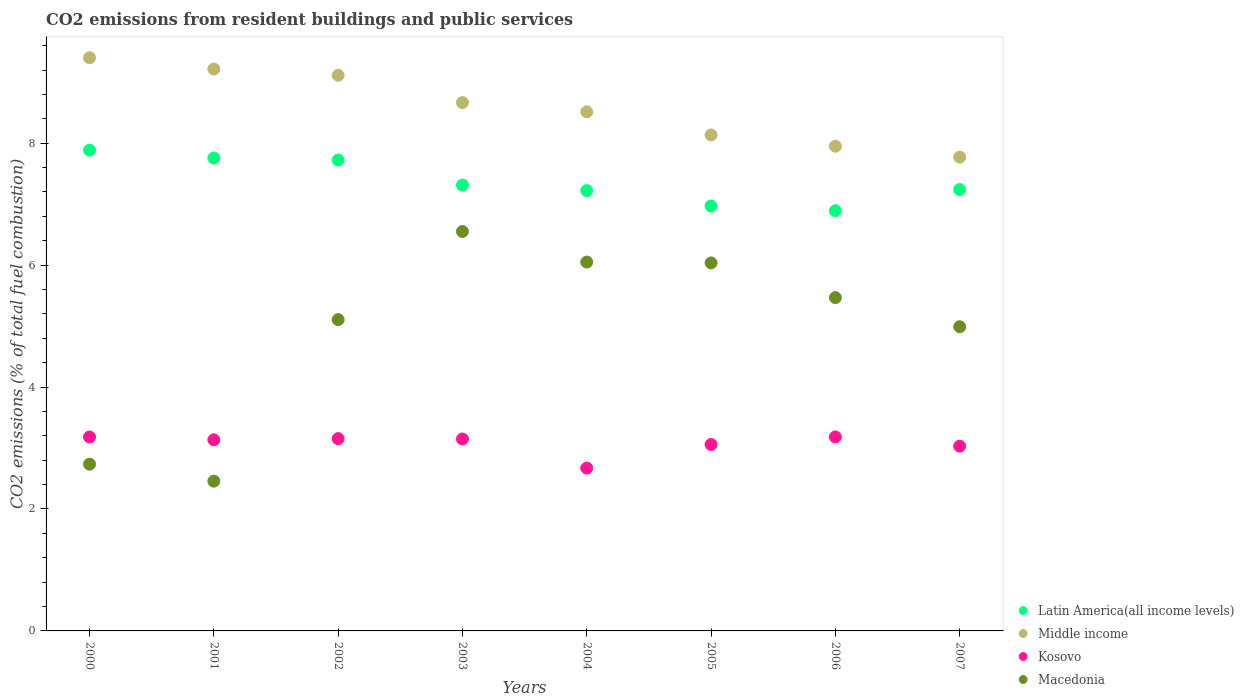What is the total CO2 emitted in Macedonia in 2002?
Give a very brief answer. 5.11. Across all years, what is the maximum total CO2 emitted in Kosovo?
Offer a very short reply. 3.18. Across all years, what is the minimum total CO2 emitted in Macedonia?
Provide a succinct answer. 2.46. In which year was the total CO2 emitted in Macedonia maximum?
Provide a short and direct response. 2003. In which year was the total CO2 emitted in Kosovo minimum?
Your answer should be compact. 2004. What is the total total CO2 emitted in Middle income in the graph?
Your response must be concise. 68.77. What is the difference between the total CO2 emitted in Middle income in 2000 and that in 2005?
Provide a short and direct response. 1.27. What is the difference between the total CO2 emitted in Middle income in 2002 and the total CO2 emitted in Latin America(all income levels) in 2003?
Provide a succinct answer. 1.8. What is the average total CO2 emitted in Kosovo per year?
Provide a short and direct response. 3.07. In the year 2003, what is the difference between the total CO2 emitted in Macedonia and total CO2 emitted in Latin America(all income levels)?
Offer a very short reply. -0.76. In how many years, is the total CO2 emitted in Middle income greater than 4.8?
Make the answer very short. 8. What is the ratio of the total CO2 emitted in Macedonia in 2001 to that in 2005?
Make the answer very short. 0.41. Is the total CO2 emitted in Latin America(all income levels) in 2002 less than that in 2004?
Your answer should be very brief. No. Is the difference between the total CO2 emitted in Macedonia in 2000 and 2005 greater than the difference between the total CO2 emitted in Latin America(all income levels) in 2000 and 2005?
Give a very brief answer. No. What is the difference between the highest and the second highest total CO2 emitted in Latin America(all income levels)?
Offer a very short reply. 0.13. What is the difference between the highest and the lowest total CO2 emitted in Middle income?
Keep it short and to the point. 1.63. Is the sum of the total CO2 emitted in Macedonia in 2002 and 2006 greater than the maximum total CO2 emitted in Kosovo across all years?
Give a very brief answer. Yes. Is it the case that in every year, the sum of the total CO2 emitted in Kosovo and total CO2 emitted in Middle income  is greater than the sum of total CO2 emitted in Macedonia and total CO2 emitted in Latin America(all income levels)?
Keep it short and to the point. No. Is the total CO2 emitted in Middle income strictly less than the total CO2 emitted in Latin America(all income levels) over the years?
Ensure brevity in your answer.  No. How many dotlines are there?
Keep it short and to the point. 4. How many years are there in the graph?
Ensure brevity in your answer.  8. Does the graph contain grids?
Offer a very short reply. No. How are the legend labels stacked?
Provide a short and direct response. Vertical. What is the title of the graph?
Your response must be concise. CO2 emissions from resident buildings and public services. What is the label or title of the Y-axis?
Keep it short and to the point. CO2 emissions (% of total fuel combustion). What is the CO2 emissions (% of total fuel combustion) in Latin America(all income levels) in 2000?
Your answer should be very brief. 7.89. What is the CO2 emissions (% of total fuel combustion) of Middle income in 2000?
Keep it short and to the point. 9.4. What is the CO2 emissions (% of total fuel combustion) of Kosovo in 2000?
Keep it short and to the point. 3.18. What is the CO2 emissions (% of total fuel combustion) in Macedonia in 2000?
Your response must be concise. 2.73. What is the CO2 emissions (% of total fuel combustion) in Latin America(all income levels) in 2001?
Your answer should be very brief. 7.76. What is the CO2 emissions (% of total fuel combustion) of Middle income in 2001?
Your response must be concise. 9.22. What is the CO2 emissions (% of total fuel combustion) in Kosovo in 2001?
Make the answer very short. 3.13. What is the CO2 emissions (% of total fuel combustion) in Macedonia in 2001?
Your answer should be very brief. 2.46. What is the CO2 emissions (% of total fuel combustion) of Latin America(all income levels) in 2002?
Make the answer very short. 7.72. What is the CO2 emissions (% of total fuel combustion) of Middle income in 2002?
Your answer should be compact. 9.11. What is the CO2 emissions (% of total fuel combustion) in Kosovo in 2002?
Offer a very short reply. 3.15. What is the CO2 emissions (% of total fuel combustion) of Macedonia in 2002?
Provide a succinct answer. 5.11. What is the CO2 emissions (% of total fuel combustion) in Latin America(all income levels) in 2003?
Provide a succinct answer. 7.31. What is the CO2 emissions (% of total fuel combustion) in Middle income in 2003?
Ensure brevity in your answer.  8.67. What is the CO2 emissions (% of total fuel combustion) in Kosovo in 2003?
Provide a short and direct response. 3.15. What is the CO2 emissions (% of total fuel combustion) of Macedonia in 2003?
Offer a terse response. 6.55. What is the CO2 emissions (% of total fuel combustion) of Latin America(all income levels) in 2004?
Your response must be concise. 7.22. What is the CO2 emissions (% of total fuel combustion) in Middle income in 2004?
Provide a short and direct response. 8.51. What is the CO2 emissions (% of total fuel combustion) of Kosovo in 2004?
Your answer should be very brief. 2.67. What is the CO2 emissions (% of total fuel combustion) of Macedonia in 2004?
Keep it short and to the point. 6.05. What is the CO2 emissions (% of total fuel combustion) of Latin America(all income levels) in 2005?
Keep it short and to the point. 6.97. What is the CO2 emissions (% of total fuel combustion) in Middle income in 2005?
Your answer should be very brief. 8.13. What is the CO2 emissions (% of total fuel combustion) in Kosovo in 2005?
Make the answer very short. 3.06. What is the CO2 emissions (% of total fuel combustion) of Macedonia in 2005?
Offer a very short reply. 6.04. What is the CO2 emissions (% of total fuel combustion) of Latin America(all income levels) in 2006?
Your answer should be very brief. 6.89. What is the CO2 emissions (% of total fuel combustion) in Middle income in 2006?
Give a very brief answer. 7.95. What is the CO2 emissions (% of total fuel combustion) of Kosovo in 2006?
Provide a succinct answer. 3.18. What is the CO2 emissions (% of total fuel combustion) of Macedonia in 2006?
Make the answer very short. 5.47. What is the CO2 emissions (% of total fuel combustion) of Latin America(all income levels) in 2007?
Ensure brevity in your answer.  7.24. What is the CO2 emissions (% of total fuel combustion) of Middle income in 2007?
Offer a terse response. 7.77. What is the CO2 emissions (% of total fuel combustion) in Kosovo in 2007?
Your response must be concise. 3.03. What is the CO2 emissions (% of total fuel combustion) in Macedonia in 2007?
Make the answer very short. 4.99. Across all years, what is the maximum CO2 emissions (% of total fuel combustion) in Latin America(all income levels)?
Your answer should be compact. 7.89. Across all years, what is the maximum CO2 emissions (% of total fuel combustion) in Middle income?
Your answer should be very brief. 9.4. Across all years, what is the maximum CO2 emissions (% of total fuel combustion) of Kosovo?
Make the answer very short. 3.18. Across all years, what is the maximum CO2 emissions (% of total fuel combustion) in Macedonia?
Give a very brief answer. 6.55. Across all years, what is the minimum CO2 emissions (% of total fuel combustion) in Latin America(all income levels)?
Keep it short and to the point. 6.89. Across all years, what is the minimum CO2 emissions (% of total fuel combustion) of Middle income?
Your answer should be very brief. 7.77. Across all years, what is the minimum CO2 emissions (% of total fuel combustion) in Kosovo?
Keep it short and to the point. 2.67. Across all years, what is the minimum CO2 emissions (% of total fuel combustion) in Macedonia?
Your response must be concise. 2.46. What is the total CO2 emissions (% of total fuel combustion) of Latin America(all income levels) in the graph?
Provide a short and direct response. 59.01. What is the total CO2 emissions (% of total fuel combustion) of Middle income in the graph?
Give a very brief answer. 68.77. What is the total CO2 emissions (% of total fuel combustion) in Kosovo in the graph?
Your answer should be compact. 24.56. What is the total CO2 emissions (% of total fuel combustion) in Macedonia in the graph?
Make the answer very short. 39.39. What is the difference between the CO2 emissions (% of total fuel combustion) of Latin America(all income levels) in 2000 and that in 2001?
Ensure brevity in your answer.  0.13. What is the difference between the CO2 emissions (% of total fuel combustion) of Middle income in 2000 and that in 2001?
Your response must be concise. 0.18. What is the difference between the CO2 emissions (% of total fuel combustion) of Kosovo in 2000 and that in 2001?
Offer a very short reply. 0.05. What is the difference between the CO2 emissions (% of total fuel combustion) of Macedonia in 2000 and that in 2001?
Make the answer very short. 0.28. What is the difference between the CO2 emissions (% of total fuel combustion) in Latin America(all income levels) in 2000 and that in 2002?
Your answer should be very brief. 0.16. What is the difference between the CO2 emissions (% of total fuel combustion) of Middle income in 2000 and that in 2002?
Ensure brevity in your answer.  0.29. What is the difference between the CO2 emissions (% of total fuel combustion) in Kosovo in 2000 and that in 2002?
Keep it short and to the point. 0.03. What is the difference between the CO2 emissions (% of total fuel combustion) in Macedonia in 2000 and that in 2002?
Your response must be concise. -2.37. What is the difference between the CO2 emissions (% of total fuel combustion) in Latin America(all income levels) in 2000 and that in 2003?
Your response must be concise. 0.57. What is the difference between the CO2 emissions (% of total fuel combustion) in Middle income in 2000 and that in 2003?
Make the answer very short. 0.74. What is the difference between the CO2 emissions (% of total fuel combustion) in Kosovo in 2000 and that in 2003?
Offer a terse response. 0.03. What is the difference between the CO2 emissions (% of total fuel combustion) in Macedonia in 2000 and that in 2003?
Provide a short and direct response. -3.82. What is the difference between the CO2 emissions (% of total fuel combustion) in Latin America(all income levels) in 2000 and that in 2004?
Provide a succinct answer. 0.66. What is the difference between the CO2 emissions (% of total fuel combustion) in Middle income in 2000 and that in 2004?
Offer a terse response. 0.89. What is the difference between the CO2 emissions (% of total fuel combustion) of Kosovo in 2000 and that in 2004?
Your answer should be compact. 0.51. What is the difference between the CO2 emissions (% of total fuel combustion) in Macedonia in 2000 and that in 2004?
Your response must be concise. -3.31. What is the difference between the CO2 emissions (% of total fuel combustion) in Latin America(all income levels) in 2000 and that in 2005?
Your response must be concise. 0.92. What is the difference between the CO2 emissions (% of total fuel combustion) in Middle income in 2000 and that in 2005?
Provide a succinct answer. 1.27. What is the difference between the CO2 emissions (% of total fuel combustion) in Kosovo in 2000 and that in 2005?
Provide a short and direct response. 0.12. What is the difference between the CO2 emissions (% of total fuel combustion) of Macedonia in 2000 and that in 2005?
Your answer should be very brief. -3.3. What is the difference between the CO2 emissions (% of total fuel combustion) of Latin America(all income levels) in 2000 and that in 2006?
Offer a terse response. 0.99. What is the difference between the CO2 emissions (% of total fuel combustion) of Middle income in 2000 and that in 2006?
Provide a short and direct response. 1.45. What is the difference between the CO2 emissions (% of total fuel combustion) of Kosovo in 2000 and that in 2006?
Offer a very short reply. -0. What is the difference between the CO2 emissions (% of total fuel combustion) in Macedonia in 2000 and that in 2006?
Keep it short and to the point. -2.73. What is the difference between the CO2 emissions (% of total fuel combustion) in Latin America(all income levels) in 2000 and that in 2007?
Offer a very short reply. 0.65. What is the difference between the CO2 emissions (% of total fuel combustion) of Middle income in 2000 and that in 2007?
Provide a short and direct response. 1.63. What is the difference between the CO2 emissions (% of total fuel combustion) in Kosovo in 2000 and that in 2007?
Make the answer very short. 0.15. What is the difference between the CO2 emissions (% of total fuel combustion) of Macedonia in 2000 and that in 2007?
Keep it short and to the point. -2.25. What is the difference between the CO2 emissions (% of total fuel combustion) in Latin America(all income levels) in 2001 and that in 2002?
Your answer should be compact. 0.03. What is the difference between the CO2 emissions (% of total fuel combustion) in Middle income in 2001 and that in 2002?
Provide a short and direct response. 0.1. What is the difference between the CO2 emissions (% of total fuel combustion) in Kosovo in 2001 and that in 2002?
Ensure brevity in your answer.  -0.02. What is the difference between the CO2 emissions (% of total fuel combustion) of Macedonia in 2001 and that in 2002?
Your answer should be very brief. -2.65. What is the difference between the CO2 emissions (% of total fuel combustion) of Latin America(all income levels) in 2001 and that in 2003?
Ensure brevity in your answer.  0.44. What is the difference between the CO2 emissions (% of total fuel combustion) in Middle income in 2001 and that in 2003?
Offer a terse response. 0.55. What is the difference between the CO2 emissions (% of total fuel combustion) in Kosovo in 2001 and that in 2003?
Your answer should be very brief. -0.01. What is the difference between the CO2 emissions (% of total fuel combustion) in Macedonia in 2001 and that in 2003?
Ensure brevity in your answer.  -4.1. What is the difference between the CO2 emissions (% of total fuel combustion) in Latin America(all income levels) in 2001 and that in 2004?
Keep it short and to the point. 0.53. What is the difference between the CO2 emissions (% of total fuel combustion) in Middle income in 2001 and that in 2004?
Offer a very short reply. 0.7. What is the difference between the CO2 emissions (% of total fuel combustion) in Kosovo in 2001 and that in 2004?
Offer a very short reply. 0.46. What is the difference between the CO2 emissions (% of total fuel combustion) of Macedonia in 2001 and that in 2004?
Your answer should be compact. -3.59. What is the difference between the CO2 emissions (% of total fuel combustion) in Latin America(all income levels) in 2001 and that in 2005?
Ensure brevity in your answer.  0.79. What is the difference between the CO2 emissions (% of total fuel combustion) of Middle income in 2001 and that in 2005?
Keep it short and to the point. 1.08. What is the difference between the CO2 emissions (% of total fuel combustion) of Kosovo in 2001 and that in 2005?
Your answer should be compact. 0.08. What is the difference between the CO2 emissions (% of total fuel combustion) in Macedonia in 2001 and that in 2005?
Your answer should be very brief. -3.58. What is the difference between the CO2 emissions (% of total fuel combustion) of Latin America(all income levels) in 2001 and that in 2006?
Give a very brief answer. 0.86. What is the difference between the CO2 emissions (% of total fuel combustion) in Middle income in 2001 and that in 2006?
Keep it short and to the point. 1.27. What is the difference between the CO2 emissions (% of total fuel combustion) of Kosovo in 2001 and that in 2006?
Provide a short and direct response. -0.05. What is the difference between the CO2 emissions (% of total fuel combustion) in Macedonia in 2001 and that in 2006?
Keep it short and to the point. -3.01. What is the difference between the CO2 emissions (% of total fuel combustion) in Latin America(all income levels) in 2001 and that in 2007?
Your answer should be very brief. 0.52. What is the difference between the CO2 emissions (% of total fuel combustion) of Middle income in 2001 and that in 2007?
Keep it short and to the point. 1.45. What is the difference between the CO2 emissions (% of total fuel combustion) of Kosovo in 2001 and that in 2007?
Offer a very short reply. 0.1. What is the difference between the CO2 emissions (% of total fuel combustion) of Macedonia in 2001 and that in 2007?
Give a very brief answer. -2.53. What is the difference between the CO2 emissions (% of total fuel combustion) in Latin America(all income levels) in 2002 and that in 2003?
Offer a very short reply. 0.41. What is the difference between the CO2 emissions (% of total fuel combustion) in Middle income in 2002 and that in 2003?
Give a very brief answer. 0.45. What is the difference between the CO2 emissions (% of total fuel combustion) of Kosovo in 2002 and that in 2003?
Give a very brief answer. 0.01. What is the difference between the CO2 emissions (% of total fuel combustion) in Macedonia in 2002 and that in 2003?
Your answer should be very brief. -1.45. What is the difference between the CO2 emissions (% of total fuel combustion) of Latin America(all income levels) in 2002 and that in 2004?
Offer a very short reply. 0.5. What is the difference between the CO2 emissions (% of total fuel combustion) of Middle income in 2002 and that in 2004?
Your response must be concise. 0.6. What is the difference between the CO2 emissions (% of total fuel combustion) in Kosovo in 2002 and that in 2004?
Keep it short and to the point. 0.48. What is the difference between the CO2 emissions (% of total fuel combustion) in Macedonia in 2002 and that in 2004?
Your response must be concise. -0.94. What is the difference between the CO2 emissions (% of total fuel combustion) in Latin America(all income levels) in 2002 and that in 2005?
Offer a terse response. 0.76. What is the difference between the CO2 emissions (% of total fuel combustion) in Middle income in 2002 and that in 2005?
Keep it short and to the point. 0.98. What is the difference between the CO2 emissions (% of total fuel combustion) in Kosovo in 2002 and that in 2005?
Your answer should be compact. 0.1. What is the difference between the CO2 emissions (% of total fuel combustion) of Macedonia in 2002 and that in 2005?
Ensure brevity in your answer.  -0.93. What is the difference between the CO2 emissions (% of total fuel combustion) in Latin America(all income levels) in 2002 and that in 2006?
Offer a very short reply. 0.83. What is the difference between the CO2 emissions (% of total fuel combustion) in Middle income in 2002 and that in 2006?
Provide a succinct answer. 1.16. What is the difference between the CO2 emissions (% of total fuel combustion) in Kosovo in 2002 and that in 2006?
Ensure brevity in your answer.  -0.03. What is the difference between the CO2 emissions (% of total fuel combustion) in Macedonia in 2002 and that in 2006?
Your response must be concise. -0.36. What is the difference between the CO2 emissions (% of total fuel combustion) of Latin America(all income levels) in 2002 and that in 2007?
Keep it short and to the point. 0.48. What is the difference between the CO2 emissions (% of total fuel combustion) in Middle income in 2002 and that in 2007?
Your answer should be very brief. 1.34. What is the difference between the CO2 emissions (% of total fuel combustion) of Kosovo in 2002 and that in 2007?
Your answer should be compact. 0.12. What is the difference between the CO2 emissions (% of total fuel combustion) in Macedonia in 2002 and that in 2007?
Offer a terse response. 0.12. What is the difference between the CO2 emissions (% of total fuel combustion) in Latin America(all income levels) in 2003 and that in 2004?
Make the answer very short. 0.09. What is the difference between the CO2 emissions (% of total fuel combustion) in Middle income in 2003 and that in 2004?
Your answer should be very brief. 0.15. What is the difference between the CO2 emissions (% of total fuel combustion) in Kosovo in 2003 and that in 2004?
Your answer should be compact. 0.48. What is the difference between the CO2 emissions (% of total fuel combustion) in Macedonia in 2003 and that in 2004?
Provide a short and direct response. 0.5. What is the difference between the CO2 emissions (% of total fuel combustion) in Latin America(all income levels) in 2003 and that in 2005?
Ensure brevity in your answer.  0.34. What is the difference between the CO2 emissions (% of total fuel combustion) of Middle income in 2003 and that in 2005?
Keep it short and to the point. 0.53. What is the difference between the CO2 emissions (% of total fuel combustion) in Kosovo in 2003 and that in 2005?
Offer a terse response. 0.09. What is the difference between the CO2 emissions (% of total fuel combustion) of Macedonia in 2003 and that in 2005?
Offer a terse response. 0.52. What is the difference between the CO2 emissions (% of total fuel combustion) in Latin America(all income levels) in 2003 and that in 2006?
Your answer should be compact. 0.42. What is the difference between the CO2 emissions (% of total fuel combustion) in Middle income in 2003 and that in 2006?
Ensure brevity in your answer.  0.72. What is the difference between the CO2 emissions (% of total fuel combustion) in Kosovo in 2003 and that in 2006?
Keep it short and to the point. -0.03. What is the difference between the CO2 emissions (% of total fuel combustion) of Macedonia in 2003 and that in 2006?
Your answer should be very brief. 1.08. What is the difference between the CO2 emissions (% of total fuel combustion) in Latin America(all income levels) in 2003 and that in 2007?
Your answer should be very brief. 0.07. What is the difference between the CO2 emissions (% of total fuel combustion) of Middle income in 2003 and that in 2007?
Offer a very short reply. 0.89. What is the difference between the CO2 emissions (% of total fuel combustion) of Kosovo in 2003 and that in 2007?
Your answer should be compact. 0.12. What is the difference between the CO2 emissions (% of total fuel combustion) of Macedonia in 2003 and that in 2007?
Your answer should be compact. 1.56. What is the difference between the CO2 emissions (% of total fuel combustion) in Latin America(all income levels) in 2004 and that in 2005?
Your answer should be very brief. 0.25. What is the difference between the CO2 emissions (% of total fuel combustion) in Middle income in 2004 and that in 2005?
Your response must be concise. 0.38. What is the difference between the CO2 emissions (% of total fuel combustion) of Kosovo in 2004 and that in 2005?
Your answer should be compact. -0.39. What is the difference between the CO2 emissions (% of total fuel combustion) of Macedonia in 2004 and that in 2005?
Keep it short and to the point. 0.01. What is the difference between the CO2 emissions (% of total fuel combustion) in Latin America(all income levels) in 2004 and that in 2006?
Your response must be concise. 0.33. What is the difference between the CO2 emissions (% of total fuel combustion) of Middle income in 2004 and that in 2006?
Give a very brief answer. 0.56. What is the difference between the CO2 emissions (% of total fuel combustion) of Kosovo in 2004 and that in 2006?
Offer a very short reply. -0.51. What is the difference between the CO2 emissions (% of total fuel combustion) of Macedonia in 2004 and that in 2006?
Provide a short and direct response. 0.58. What is the difference between the CO2 emissions (% of total fuel combustion) in Latin America(all income levels) in 2004 and that in 2007?
Your answer should be very brief. -0.02. What is the difference between the CO2 emissions (% of total fuel combustion) of Middle income in 2004 and that in 2007?
Provide a succinct answer. 0.74. What is the difference between the CO2 emissions (% of total fuel combustion) of Kosovo in 2004 and that in 2007?
Offer a terse response. -0.36. What is the difference between the CO2 emissions (% of total fuel combustion) in Macedonia in 2004 and that in 2007?
Make the answer very short. 1.06. What is the difference between the CO2 emissions (% of total fuel combustion) of Latin America(all income levels) in 2005 and that in 2006?
Provide a short and direct response. 0.08. What is the difference between the CO2 emissions (% of total fuel combustion) of Middle income in 2005 and that in 2006?
Your answer should be compact. 0.18. What is the difference between the CO2 emissions (% of total fuel combustion) in Kosovo in 2005 and that in 2006?
Your response must be concise. -0.12. What is the difference between the CO2 emissions (% of total fuel combustion) in Macedonia in 2005 and that in 2006?
Offer a terse response. 0.57. What is the difference between the CO2 emissions (% of total fuel combustion) in Latin America(all income levels) in 2005 and that in 2007?
Provide a succinct answer. -0.27. What is the difference between the CO2 emissions (% of total fuel combustion) in Middle income in 2005 and that in 2007?
Your answer should be very brief. 0.36. What is the difference between the CO2 emissions (% of total fuel combustion) in Kosovo in 2005 and that in 2007?
Your answer should be compact. 0.03. What is the difference between the CO2 emissions (% of total fuel combustion) in Macedonia in 2005 and that in 2007?
Ensure brevity in your answer.  1.05. What is the difference between the CO2 emissions (% of total fuel combustion) in Latin America(all income levels) in 2006 and that in 2007?
Your answer should be compact. -0.35. What is the difference between the CO2 emissions (% of total fuel combustion) in Middle income in 2006 and that in 2007?
Keep it short and to the point. 0.18. What is the difference between the CO2 emissions (% of total fuel combustion) in Kosovo in 2006 and that in 2007?
Offer a very short reply. 0.15. What is the difference between the CO2 emissions (% of total fuel combustion) of Macedonia in 2006 and that in 2007?
Make the answer very short. 0.48. What is the difference between the CO2 emissions (% of total fuel combustion) of Latin America(all income levels) in 2000 and the CO2 emissions (% of total fuel combustion) of Middle income in 2001?
Keep it short and to the point. -1.33. What is the difference between the CO2 emissions (% of total fuel combustion) of Latin America(all income levels) in 2000 and the CO2 emissions (% of total fuel combustion) of Kosovo in 2001?
Give a very brief answer. 4.75. What is the difference between the CO2 emissions (% of total fuel combustion) of Latin America(all income levels) in 2000 and the CO2 emissions (% of total fuel combustion) of Macedonia in 2001?
Give a very brief answer. 5.43. What is the difference between the CO2 emissions (% of total fuel combustion) of Middle income in 2000 and the CO2 emissions (% of total fuel combustion) of Kosovo in 2001?
Provide a succinct answer. 6.27. What is the difference between the CO2 emissions (% of total fuel combustion) in Middle income in 2000 and the CO2 emissions (% of total fuel combustion) in Macedonia in 2001?
Your answer should be very brief. 6.95. What is the difference between the CO2 emissions (% of total fuel combustion) of Kosovo in 2000 and the CO2 emissions (% of total fuel combustion) of Macedonia in 2001?
Your answer should be compact. 0.72. What is the difference between the CO2 emissions (% of total fuel combustion) in Latin America(all income levels) in 2000 and the CO2 emissions (% of total fuel combustion) in Middle income in 2002?
Your answer should be very brief. -1.23. What is the difference between the CO2 emissions (% of total fuel combustion) of Latin America(all income levels) in 2000 and the CO2 emissions (% of total fuel combustion) of Kosovo in 2002?
Make the answer very short. 4.73. What is the difference between the CO2 emissions (% of total fuel combustion) in Latin America(all income levels) in 2000 and the CO2 emissions (% of total fuel combustion) in Macedonia in 2002?
Offer a terse response. 2.78. What is the difference between the CO2 emissions (% of total fuel combustion) in Middle income in 2000 and the CO2 emissions (% of total fuel combustion) in Kosovo in 2002?
Your answer should be very brief. 6.25. What is the difference between the CO2 emissions (% of total fuel combustion) of Middle income in 2000 and the CO2 emissions (% of total fuel combustion) of Macedonia in 2002?
Offer a very short reply. 4.3. What is the difference between the CO2 emissions (% of total fuel combustion) of Kosovo in 2000 and the CO2 emissions (% of total fuel combustion) of Macedonia in 2002?
Your response must be concise. -1.92. What is the difference between the CO2 emissions (% of total fuel combustion) in Latin America(all income levels) in 2000 and the CO2 emissions (% of total fuel combustion) in Middle income in 2003?
Offer a terse response. -0.78. What is the difference between the CO2 emissions (% of total fuel combustion) of Latin America(all income levels) in 2000 and the CO2 emissions (% of total fuel combustion) of Kosovo in 2003?
Offer a very short reply. 4.74. What is the difference between the CO2 emissions (% of total fuel combustion) in Latin America(all income levels) in 2000 and the CO2 emissions (% of total fuel combustion) in Macedonia in 2003?
Provide a short and direct response. 1.33. What is the difference between the CO2 emissions (% of total fuel combustion) of Middle income in 2000 and the CO2 emissions (% of total fuel combustion) of Kosovo in 2003?
Provide a succinct answer. 6.25. What is the difference between the CO2 emissions (% of total fuel combustion) of Middle income in 2000 and the CO2 emissions (% of total fuel combustion) of Macedonia in 2003?
Offer a terse response. 2.85. What is the difference between the CO2 emissions (% of total fuel combustion) of Kosovo in 2000 and the CO2 emissions (% of total fuel combustion) of Macedonia in 2003?
Ensure brevity in your answer.  -3.37. What is the difference between the CO2 emissions (% of total fuel combustion) in Latin America(all income levels) in 2000 and the CO2 emissions (% of total fuel combustion) in Middle income in 2004?
Your answer should be compact. -0.63. What is the difference between the CO2 emissions (% of total fuel combustion) of Latin America(all income levels) in 2000 and the CO2 emissions (% of total fuel combustion) of Kosovo in 2004?
Your response must be concise. 5.21. What is the difference between the CO2 emissions (% of total fuel combustion) of Latin America(all income levels) in 2000 and the CO2 emissions (% of total fuel combustion) of Macedonia in 2004?
Offer a terse response. 1.84. What is the difference between the CO2 emissions (% of total fuel combustion) in Middle income in 2000 and the CO2 emissions (% of total fuel combustion) in Kosovo in 2004?
Your answer should be very brief. 6.73. What is the difference between the CO2 emissions (% of total fuel combustion) in Middle income in 2000 and the CO2 emissions (% of total fuel combustion) in Macedonia in 2004?
Your answer should be compact. 3.35. What is the difference between the CO2 emissions (% of total fuel combustion) of Kosovo in 2000 and the CO2 emissions (% of total fuel combustion) of Macedonia in 2004?
Make the answer very short. -2.87. What is the difference between the CO2 emissions (% of total fuel combustion) in Latin America(all income levels) in 2000 and the CO2 emissions (% of total fuel combustion) in Middle income in 2005?
Ensure brevity in your answer.  -0.25. What is the difference between the CO2 emissions (% of total fuel combustion) of Latin America(all income levels) in 2000 and the CO2 emissions (% of total fuel combustion) of Kosovo in 2005?
Give a very brief answer. 4.83. What is the difference between the CO2 emissions (% of total fuel combustion) in Latin America(all income levels) in 2000 and the CO2 emissions (% of total fuel combustion) in Macedonia in 2005?
Give a very brief answer. 1.85. What is the difference between the CO2 emissions (% of total fuel combustion) in Middle income in 2000 and the CO2 emissions (% of total fuel combustion) in Kosovo in 2005?
Your answer should be compact. 6.34. What is the difference between the CO2 emissions (% of total fuel combustion) of Middle income in 2000 and the CO2 emissions (% of total fuel combustion) of Macedonia in 2005?
Give a very brief answer. 3.37. What is the difference between the CO2 emissions (% of total fuel combustion) of Kosovo in 2000 and the CO2 emissions (% of total fuel combustion) of Macedonia in 2005?
Your answer should be compact. -2.86. What is the difference between the CO2 emissions (% of total fuel combustion) of Latin America(all income levels) in 2000 and the CO2 emissions (% of total fuel combustion) of Middle income in 2006?
Make the answer very short. -0.07. What is the difference between the CO2 emissions (% of total fuel combustion) of Latin America(all income levels) in 2000 and the CO2 emissions (% of total fuel combustion) of Kosovo in 2006?
Ensure brevity in your answer.  4.7. What is the difference between the CO2 emissions (% of total fuel combustion) of Latin America(all income levels) in 2000 and the CO2 emissions (% of total fuel combustion) of Macedonia in 2006?
Make the answer very short. 2.42. What is the difference between the CO2 emissions (% of total fuel combustion) of Middle income in 2000 and the CO2 emissions (% of total fuel combustion) of Kosovo in 2006?
Offer a terse response. 6.22. What is the difference between the CO2 emissions (% of total fuel combustion) in Middle income in 2000 and the CO2 emissions (% of total fuel combustion) in Macedonia in 2006?
Your answer should be very brief. 3.93. What is the difference between the CO2 emissions (% of total fuel combustion) of Kosovo in 2000 and the CO2 emissions (% of total fuel combustion) of Macedonia in 2006?
Provide a succinct answer. -2.29. What is the difference between the CO2 emissions (% of total fuel combustion) of Latin America(all income levels) in 2000 and the CO2 emissions (% of total fuel combustion) of Middle income in 2007?
Provide a succinct answer. 0.11. What is the difference between the CO2 emissions (% of total fuel combustion) in Latin America(all income levels) in 2000 and the CO2 emissions (% of total fuel combustion) in Kosovo in 2007?
Ensure brevity in your answer.  4.86. What is the difference between the CO2 emissions (% of total fuel combustion) of Latin America(all income levels) in 2000 and the CO2 emissions (% of total fuel combustion) of Macedonia in 2007?
Provide a succinct answer. 2.9. What is the difference between the CO2 emissions (% of total fuel combustion) in Middle income in 2000 and the CO2 emissions (% of total fuel combustion) in Kosovo in 2007?
Your response must be concise. 6.37. What is the difference between the CO2 emissions (% of total fuel combustion) of Middle income in 2000 and the CO2 emissions (% of total fuel combustion) of Macedonia in 2007?
Your response must be concise. 4.41. What is the difference between the CO2 emissions (% of total fuel combustion) of Kosovo in 2000 and the CO2 emissions (% of total fuel combustion) of Macedonia in 2007?
Offer a very short reply. -1.81. What is the difference between the CO2 emissions (% of total fuel combustion) in Latin America(all income levels) in 2001 and the CO2 emissions (% of total fuel combustion) in Middle income in 2002?
Your response must be concise. -1.36. What is the difference between the CO2 emissions (% of total fuel combustion) of Latin America(all income levels) in 2001 and the CO2 emissions (% of total fuel combustion) of Kosovo in 2002?
Provide a succinct answer. 4.6. What is the difference between the CO2 emissions (% of total fuel combustion) of Latin America(all income levels) in 2001 and the CO2 emissions (% of total fuel combustion) of Macedonia in 2002?
Your response must be concise. 2.65. What is the difference between the CO2 emissions (% of total fuel combustion) of Middle income in 2001 and the CO2 emissions (% of total fuel combustion) of Kosovo in 2002?
Give a very brief answer. 6.06. What is the difference between the CO2 emissions (% of total fuel combustion) in Middle income in 2001 and the CO2 emissions (% of total fuel combustion) in Macedonia in 2002?
Your answer should be compact. 4.11. What is the difference between the CO2 emissions (% of total fuel combustion) of Kosovo in 2001 and the CO2 emissions (% of total fuel combustion) of Macedonia in 2002?
Your answer should be compact. -1.97. What is the difference between the CO2 emissions (% of total fuel combustion) of Latin America(all income levels) in 2001 and the CO2 emissions (% of total fuel combustion) of Middle income in 2003?
Provide a short and direct response. -0.91. What is the difference between the CO2 emissions (% of total fuel combustion) of Latin America(all income levels) in 2001 and the CO2 emissions (% of total fuel combustion) of Kosovo in 2003?
Your answer should be very brief. 4.61. What is the difference between the CO2 emissions (% of total fuel combustion) of Latin America(all income levels) in 2001 and the CO2 emissions (% of total fuel combustion) of Macedonia in 2003?
Your answer should be compact. 1.21. What is the difference between the CO2 emissions (% of total fuel combustion) of Middle income in 2001 and the CO2 emissions (% of total fuel combustion) of Kosovo in 2003?
Offer a very short reply. 6.07. What is the difference between the CO2 emissions (% of total fuel combustion) in Middle income in 2001 and the CO2 emissions (% of total fuel combustion) in Macedonia in 2003?
Keep it short and to the point. 2.66. What is the difference between the CO2 emissions (% of total fuel combustion) in Kosovo in 2001 and the CO2 emissions (% of total fuel combustion) in Macedonia in 2003?
Your response must be concise. -3.42. What is the difference between the CO2 emissions (% of total fuel combustion) in Latin America(all income levels) in 2001 and the CO2 emissions (% of total fuel combustion) in Middle income in 2004?
Your answer should be compact. -0.76. What is the difference between the CO2 emissions (% of total fuel combustion) of Latin America(all income levels) in 2001 and the CO2 emissions (% of total fuel combustion) of Kosovo in 2004?
Offer a terse response. 5.09. What is the difference between the CO2 emissions (% of total fuel combustion) in Latin America(all income levels) in 2001 and the CO2 emissions (% of total fuel combustion) in Macedonia in 2004?
Offer a very short reply. 1.71. What is the difference between the CO2 emissions (% of total fuel combustion) of Middle income in 2001 and the CO2 emissions (% of total fuel combustion) of Kosovo in 2004?
Your response must be concise. 6.55. What is the difference between the CO2 emissions (% of total fuel combustion) of Middle income in 2001 and the CO2 emissions (% of total fuel combustion) of Macedonia in 2004?
Ensure brevity in your answer.  3.17. What is the difference between the CO2 emissions (% of total fuel combustion) in Kosovo in 2001 and the CO2 emissions (% of total fuel combustion) in Macedonia in 2004?
Keep it short and to the point. -2.92. What is the difference between the CO2 emissions (% of total fuel combustion) of Latin America(all income levels) in 2001 and the CO2 emissions (% of total fuel combustion) of Middle income in 2005?
Offer a very short reply. -0.38. What is the difference between the CO2 emissions (% of total fuel combustion) of Latin America(all income levels) in 2001 and the CO2 emissions (% of total fuel combustion) of Kosovo in 2005?
Offer a very short reply. 4.7. What is the difference between the CO2 emissions (% of total fuel combustion) of Latin America(all income levels) in 2001 and the CO2 emissions (% of total fuel combustion) of Macedonia in 2005?
Offer a very short reply. 1.72. What is the difference between the CO2 emissions (% of total fuel combustion) of Middle income in 2001 and the CO2 emissions (% of total fuel combustion) of Kosovo in 2005?
Your answer should be very brief. 6.16. What is the difference between the CO2 emissions (% of total fuel combustion) of Middle income in 2001 and the CO2 emissions (% of total fuel combustion) of Macedonia in 2005?
Ensure brevity in your answer.  3.18. What is the difference between the CO2 emissions (% of total fuel combustion) of Kosovo in 2001 and the CO2 emissions (% of total fuel combustion) of Macedonia in 2005?
Ensure brevity in your answer.  -2.9. What is the difference between the CO2 emissions (% of total fuel combustion) in Latin America(all income levels) in 2001 and the CO2 emissions (% of total fuel combustion) in Middle income in 2006?
Make the answer very short. -0.19. What is the difference between the CO2 emissions (% of total fuel combustion) of Latin America(all income levels) in 2001 and the CO2 emissions (% of total fuel combustion) of Kosovo in 2006?
Your response must be concise. 4.58. What is the difference between the CO2 emissions (% of total fuel combustion) of Latin America(all income levels) in 2001 and the CO2 emissions (% of total fuel combustion) of Macedonia in 2006?
Offer a terse response. 2.29. What is the difference between the CO2 emissions (% of total fuel combustion) in Middle income in 2001 and the CO2 emissions (% of total fuel combustion) in Kosovo in 2006?
Keep it short and to the point. 6.03. What is the difference between the CO2 emissions (% of total fuel combustion) in Middle income in 2001 and the CO2 emissions (% of total fuel combustion) in Macedonia in 2006?
Provide a succinct answer. 3.75. What is the difference between the CO2 emissions (% of total fuel combustion) of Kosovo in 2001 and the CO2 emissions (% of total fuel combustion) of Macedonia in 2006?
Your answer should be very brief. -2.33. What is the difference between the CO2 emissions (% of total fuel combustion) of Latin America(all income levels) in 2001 and the CO2 emissions (% of total fuel combustion) of Middle income in 2007?
Make the answer very short. -0.01. What is the difference between the CO2 emissions (% of total fuel combustion) of Latin America(all income levels) in 2001 and the CO2 emissions (% of total fuel combustion) of Kosovo in 2007?
Provide a succinct answer. 4.73. What is the difference between the CO2 emissions (% of total fuel combustion) in Latin America(all income levels) in 2001 and the CO2 emissions (% of total fuel combustion) in Macedonia in 2007?
Provide a short and direct response. 2.77. What is the difference between the CO2 emissions (% of total fuel combustion) of Middle income in 2001 and the CO2 emissions (% of total fuel combustion) of Kosovo in 2007?
Provide a succinct answer. 6.19. What is the difference between the CO2 emissions (% of total fuel combustion) of Middle income in 2001 and the CO2 emissions (% of total fuel combustion) of Macedonia in 2007?
Offer a terse response. 4.23. What is the difference between the CO2 emissions (% of total fuel combustion) in Kosovo in 2001 and the CO2 emissions (% of total fuel combustion) in Macedonia in 2007?
Provide a succinct answer. -1.85. What is the difference between the CO2 emissions (% of total fuel combustion) of Latin America(all income levels) in 2002 and the CO2 emissions (% of total fuel combustion) of Middle income in 2003?
Offer a terse response. -0.94. What is the difference between the CO2 emissions (% of total fuel combustion) of Latin America(all income levels) in 2002 and the CO2 emissions (% of total fuel combustion) of Kosovo in 2003?
Make the answer very short. 4.58. What is the difference between the CO2 emissions (% of total fuel combustion) in Latin America(all income levels) in 2002 and the CO2 emissions (% of total fuel combustion) in Macedonia in 2003?
Keep it short and to the point. 1.17. What is the difference between the CO2 emissions (% of total fuel combustion) of Middle income in 2002 and the CO2 emissions (% of total fuel combustion) of Kosovo in 2003?
Keep it short and to the point. 5.97. What is the difference between the CO2 emissions (% of total fuel combustion) in Middle income in 2002 and the CO2 emissions (% of total fuel combustion) in Macedonia in 2003?
Give a very brief answer. 2.56. What is the difference between the CO2 emissions (% of total fuel combustion) in Kosovo in 2002 and the CO2 emissions (% of total fuel combustion) in Macedonia in 2003?
Give a very brief answer. -3.4. What is the difference between the CO2 emissions (% of total fuel combustion) of Latin America(all income levels) in 2002 and the CO2 emissions (% of total fuel combustion) of Middle income in 2004?
Provide a succinct answer. -0.79. What is the difference between the CO2 emissions (% of total fuel combustion) in Latin America(all income levels) in 2002 and the CO2 emissions (% of total fuel combustion) in Kosovo in 2004?
Your answer should be very brief. 5.05. What is the difference between the CO2 emissions (% of total fuel combustion) in Latin America(all income levels) in 2002 and the CO2 emissions (% of total fuel combustion) in Macedonia in 2004?
Make the answer very short. 1.67. What is the difference between the CO2 emissions (% of total fuel combustion) in Middle income in 2002 and the CO2 emissions (% of total fuel combustion) in Kosovo in 2004?
Keep it short and to the point. 6.44. What is the difference between the CO2 emissions (% of total fuel combustion) of Middle income in 2002 and the CO2 emissions (% of total fuel combustion) of Macedonia in 2004?
Make the answer very short. 3.06. What is the difference between the CO2 emissions (% of total fuel combustion) in Kosovo in 2002 and the CO2 emissions (% of total fuel combustion) in Macedonia in 2004?
Provide a succinct answer. -2.9. What is the difference between the CO2 emissions (% of total fuel combustion) in Latin America(all income levels) in 2002 and the CO2 emissions (% of total fuel combustion) in Middle income in 2005?
Provide a succinct answer. -0.41. What is the difference between the CO2 emissions (% of total fuel combustion) in Latin America(all income levels) in 2002 and the CO2 emissions (% of total fuel combustion) in Kosovo in 2005?
Provide a succinct answer. 4.67. What is the difference between the CO2 emissions (% of total fuel combustion) of Latin America(all income levels) in 2002 and the CO2 emissions (% of total fuel combustion) of Macedonia in 2005?
Ensure brevity in your answer.  1.69. What is the difference between the CO2 emissions (% of total fuel combustion) of Middle income in 2002 and the CO2 emissions (% of total fuel combustion) of Kosovo in 2005?
Make the answer very short. 6.06. What is the difference between the CO2 emissions (% of total fuel combustion) in Middle income in 2002 and the CO2 emissions (% of total fuel combustion) in Macedonia in 2005?
Keep it short and to the point. 3.08. What is the difference between the CO2 emissions (% of total fuel combustion) in Kosovo in 2002 and the CO2 emissions (% of total fuel combustion) in Macedonia in 2005?
Your answer should be compact. -2.88. What is the difference between the CO2 emissions (% of total fuel combustion) in Latin America(all income levels) in 2002 and the CO2 emissions (% of total fuel combustion) in Middle income in 2006?
Give a very brief answer. -0.23. What is the difference between the CO2 emissions (% of total fuel combustion) in Latin America(all income levels) in 2002 and the CO2 emissions (% of total fuel combustion) in Kosovo in 2006?
Provide a succinct answer. 4.54. What is the difference between the CO2 emissions (% of total fuel combustion) in Latin America(all income levels) in 2002 and the CO2 emissions (% of total fuel combustion) in Macedonia in 2006?
Provide a short and direct response. 2.26. What is the difference between the CO2 emissions (% of total fuel combustion) in Middle income in 2002 and the CO2 emissions (% of total fuel combustion) in Kosovo in 2006?
Your answer should be compact. 5.93. What is the difference between the CO2 emissions (% of total fuel combustion) of Middle income in 2002 and the CO2 emissions (% of total fuel combustion) of Macedonia in 2006?
Provide a short and direct response. 3.65. What is the difference between the CO2 emissions (% of total fuel combustion) of Kosovo in 2002 and the CO2 emissions (% of total fuel combustion) of Macedonia in 2006?
Make the answer very short. -2.31. What is the difference between the CO2 emissions (% of total fuel combustion) in Latin America(all income levels) in 2002 and the CO2 emissions (% of total fuel combustion) in Middle income in 2007?
Provide a succinct answer. -0.05. What is the difference between the CO2 emissions (% of total fuel combustion) in Latin America(all income levels) in 2002 and the CO2 emissions (% of total fuel combustion) in Kosovo in 2007?
Keep it short and to the point. 4.69. What is the difference between the CO2 emissions (% of total fuel combustion) of Latin America(all income levels) in 2002 and the CO2 emissions (% of total fuel combustion) of Macedonia in 2007?
Your answer should be compact. 2.74. What is the difference between the CO2 emissions (% of total fuel combustion) in Middle income in 2002 and the CO2 emissions (% of total fuel combustion) in Kosovo in 2007?
Provide a short and direct response. 6.08. What is the difference between the CO2 emissions (% of total fuel combustion) in Middle income in 2002 and the CO2 emissions (% of total fuel combustion) in Macedonia in 2007?
Give a very brief answer. 4.12. What is the difference between the CO2 emissions (% of total fuel combustion) in Kosovo in 2002 and the CO2 emissions (% of total fuel combustion) in Macedonia in 2007?
Ensure brevity in your answer.  -1.83. What is the difference between the CO2 emissions (% of total fuel combustion) of Latin America(all income levels) in 2003 and the CO2 emissions (% of total fuel combustion) of Middle income in 2004?
Keep it short and to the point. -1.2. What is the difference between the CO2 emissions (% of total fuel combustion) of Latin America(all income levels) in 2003 and the CO2 emissions (% of total fuel combustion) of Kosovo in 2004?
Provide a succinct answer. 4.64. What is the difference between the CO2 emissions (% of total fuel combustion) in Latin America(all income levels) in 2003 and the CO2 emissions (% of total fuel combustion) in Macedonia in 2004?
Provide a short and direct response. 1.26. What is the difference between the CO2 emissions (% of total fuel combustion) in Middle income in 2003 and the CO2 emissions (% of total fuel combustion) in Kosovo in 2004?
Give a very brief answer. 6. What is the difference between the CO2 emissions (% of total fuel combustion) in Middle income in 2003 and the CO2 emissions (% of total fuel combustion) in Macedonia in 2004?
Your answer should be compact. 2.62. What is the difference between the CO2 emissions (% of total fuel combustion) of Kosovo in 2003 and the CO2 emissions (% of total fuel combustion) of Macedonia in 2004?
Your response must be concise. -2.9. What is the difference between the CO2 emissions (% of total fuel combustion) of Latin America(all income levels) in 2003 and the CO2 emissions (% of total fuel combustion) of Middle income in 2005?
Your response must be concise. -0.82. What is the difference between the CO2 emissions (% of total fuel combustion) in Latin America(all income levels) in 2003 and the CO2 emissions (% of total fuel combustion) in Kosovo in 2005?
Your answer should be very brief. 4.26. What is the difference between the CO2 emissions (% of total fuel combustion) in Latin America(all income levels) in 2003 and the CO2 emissions (% of total fuel combustion) in Macedonia in 2005?
Give a very brief answer. 1.28. What is the difference between the CO2 emissions (% of total fuel combustion) in Middle income in 2003 and the CO2 emissions (% of total fuel combustion) in Kosovo in 2005?
Offer a very short reply. 5.61. What is the difference between the CO2 emissions (% of total fuel combustion) in Middle income in 2003 and the CO2 emissions (% of total fuel combustion) in Macedonia in 2005?
Provide a short and direct response. 2.63. What is the difference between the CO2 emissions (% of total fuel combustion) in Kosovo in 2003 and the CO2 emissions (% of total fuel combustion) in Macedonia in 2005?
Ensure brevity in your answer.  -2.89. What is the difference between the CO2 emissions (% of total fuel combustion) of Latin America(all income levels) in 2003 and the CO2 emissions (% of total fuel combustion) of Middle income in 2006?
Your response must be concise. -0.64. What is the difference between the CO2 emissions (% of total fuel combustion) of Latin America(all income levels) in 2003 and the CO2 emissions (% of total fuel combustion) of Kosovo in 2006?
Offer a very short reply. 4.13. What is the difference between the CO2 emissions (% of total fuel combustion) in Latin America(all income levels) in 2003 and the CO2 emissions (% of total fuel combustion) in Macedonia in 2006?
Your response must be concise. 1.85. What is the difference between the CO2 emissions (% of total fuel combustion) of Middle income in 2003 and the CO2 emissions (% of total fuel combustion) of Kosovo in 2006?
Make the answer very short. 5.48. What is the difference between the CO2 emissions (% of total fuel combustion) in Middle income in 2003 and the CO2 emissions (% of total fuel combustion) in Macedonia in 2006?
Your response must be concise. 3.2. What is the difference between the CO2 emissions (% of total fuel combustion) in Kosovo in 2003 and the CO2 emissions (% of total fuel combustion) in Macedonia in 2006?
Your answer should be compact. -2.32. What is the difference between the CO2 emissions (% of total fuel combustion) in Latin America(all income levels) in 2003 and the CO2 emissions (% of total fuel combustion) in Middle income in 2007?
Provide a succinct answer. -0.46. What is the difference between the CO2 emissions (% of total fuel combustion) in Latin America(all income levels) in 2003 and the CO2 emissions (% of total fuel combustion) in Kosovo in 2007?
Give a very brief answer. 4.28. What is the difference between the CO2 emissions (% of total fuel combustion) of Latin America(all income levels) in 2003 and the CO2 emissions (% of total fuel combustion) of Macedonia in 2007?
Offer a terse response. 2.32. What is the difference between the CO2 emissions (% of total fuel combustion) in Middle income in 2003 and the CO2 emissions (% of total fuel combustion) in Kosovo in 2007?
Ensure brevity in your answer.  5.64. What is the difference between the CO2 emissions (% of total fuel combustion) of Middle income in 2003 and the CO2 emissions (% of total fuel combustion) of Macedonia in 2007?
Offer a terse response. 3.68. What is the difference between the CO2 emissions (% of total fuel combustion) of Kosovo in 2003 and the CO2 emissions (% of total fuel combustion) of Macedonia in 2007?
Make the answer very short. -1.84. What is the difference between the CO2 emissions (% of total fuel combustion) of Latin America(all income levels) in 2004 and the CO2 emissions (% of total fuel combustion) of Middle income in 2005?
Ensure brevity in your answer.  -0.91. What is the difference between the CO2 emissions (% of total fuel combustion) in Latin America(all income levels) in 2004 and the CO2 emissions (% of total fuel combustion) in Kosovo in 2005?
Provide a succinct answer. 4.16. What is the difference between the CO2 emissions (% of total fuel combustion) in Latin America(all income levels) in 2004 and the CO2 emissions (% of total fuel combustion) in Macedonia in 2005?
Your answer should be very brief. 1.19. What is the difference between the CO2 emissions (% of total fuel combustion) of Middle income in 2004 and the CO2 emissions (% of total fuel combustion) of Kosovo in 2005?
Your answer should be compact. 5.46. What is the difference between the CO2 emissions (% of total fuel combustion) of Middle income in 2004 and the CO2 emissions (% of total fuel combustion) of Macedonia in 2005?
Your response must be concise. 2.48. What is the difference between the CO2 emissions (% of total fuel combustion) in Kosovo in 2004 and the CO2 emissions (% of total fuel combustion) in Macedonia in 2005?
Offer a very short reply. -3.37. What is the difference between the CO2 emissions (% of total fuel combustion) of Latin America(all income levels) in 2004 and the CO2 emissions (% of total fuel combustion) of Middle income in 2006?
Your response must be concise. -0.73. What is the difference between the CO2 emissions (% of total fuel combustion) in Latin America(all income levels) in 2004 and the CO2 emissions (% of total fuel combustion) in Kosovo in 2006?
Offer a very short reply. 4.04. What is the difference between the CO2 emissions (% of total fuel combustion) in Latin America(all income levels) in 2004 and the CO2 emissions (% of total fuel combustion) in Macedonia in 2006?
Your answer should be compact. 1.76. What is the difference between the CO2 emissions (% of total fuel combustion) in Middle income in 2004 and the CO2 emissions (% of total fuel combustion) in Kosovo in 2006?
Give a very brief answer. 5.33. What is the difference between the CO2 emissions (% of total fuel combustion) in Middle income in 2004 and the CO2 emissions (% of total fuel combustion) in Macedonia in 2006?
Your response must be concise. 3.05. What is the difference between the CO2 emissions (% of total fuel combustion) of Kosovo in 2004 and the CO2 emissions (% of total fuel combustion) of Macedonia in 2006?
Make the answer very short. -2.8. What is the difference between the CO2 emissions (% of total fuel combustion) in Latin America(all income levels) in 2004 and the CO2 emissions (% of total fuel combustion) in Middle income in 2007?
Provide a short and direct response. -0.55. What is the difference between the CO2 emissions (% of total fuel combustion) of Latin America(all income levels) in 2004 and the CO2 emissions (% of total fuel combustion) of Kosovo in 2007?
Provide a short and direct response. 4.19. What is the difference between the CO2 emissions (% of total fuel combustion) of Latin America(all income levels) in 2004 and the CO2 emissions (% of total fuel combustion) of Macedonia in 2007?
Make the answer very short. 2.23. What is the difference between the CO2 emissions (% of total fuel combustion) in Middle income in 2004 and the CO2 emissions (% of total fuel combustion) in Kosovo in 2007?
Keep it short and to the point. 5.48. What is the difference between the CO2 emissions (% of total fuel combustion) in Middle income in 2004 and the CO2 emissions (% of total fuel combustion) in Macedonia in 2007?
Offer a terse response. 3.52. What is the difference between the CO2 emissions (% of total fuel combustion) of Kosovo in 2004 and the CO2 emissions (% of total fuel combustion) of Macedonia in 2007?
Your answer should be compact. -2.32. What is the difference between the CO2 emissions (% of total fuel combustion) in Latin America(all income levels) in 2005 and the CO2 emissions (% of total fuel combustion) in Middle income in 2006?
Provide a short and direct response. -0.98. What is the difference between the CO2 emissions (% of total fuel combustion) in Latin America(all income levels) in 2005 and the CO2 emissions (% of total fuel combustion) in Kosovo in 2006?
Keep it short and to the point. 3.79. What is the difference between the CO2 emissions (% of total fuel combustion) in Latin America(all income levels) in 2005 and the CO2 emissions (% of total fuel combustion) in Macedonia in 2006?
Provide a short and direct response. 1.5. What is the difference between the CO2 emissions (% of total fuel combustion) of Middle income in 2005 and the CO2 emissions (% of total fuel combustion) of Kosovo in 2006?
Offer a terse response. 4.95. What is the difference between the CO2 emissions (% of total fuel combustion) in Middle income in 2005 and the CO2 emissions (% of total fuel combustion) in Macedonia in 2006?
Offer a very short reply. 2.67. What is the difference between the CO2 emissions (% of total fuel combustion) in Kosovo in 2005 and the CO2 emissions (% of total fuel combustion) in Macedonia in 2006?
Provide a short and direct response. -2.41. What is the difference between the CO2 emissions (% of total fuel combustion) in Latin America(all income levels) in 2005 and the CO2 emissions (% of total fuel combustion) in Middle income in 2007?
Give a very brief answer. -0.8. What is the difference between the CO2 emissions (% of total fuel combustion) in Latin America(all income levels) in 2005 and the CO2 emissions (% of total fuel combustion) in Kosovo in 2007?
Give a very brief answer. 3.94. What is the difference between the CO2 emissions (% of total fuel combustion) in Latin America(all income levels) in 2005 and the CO2 emissions (% of total fuel combustion) in Macedonia in 2007?
Your answer should be compact. 1.98. What is the difference between the CO2 emissions (% of total fuel combustion) in Middle income in 2005 and the CO2 emissions (% of total fuel combustion) in Kosovo in 2007?
Make the answer very short. 5.1. What is the difference between the CO2 emissions (% of total fuel combustion) of Middle income in 2005 and the CO2 emissions (% of total fuel combustion) of Macedonia in 2007?
Keep it short and to the point. 3.15. What is the difference between the CO2 emissions (% of total fuel combustion) of Kosovo in 2005 and the CO2 emissions (% of total fuel combustion) of Macedonia in 2007?
Your answer should be compact. -1.93. What is the difference between the CO2 emissions (% of total fuel combustion) of Latin America(all income levels) in 2006 and the CO2 emissions (% of total fuel combustion) of Middle income in 2007?
Keep it short and to the point. -0.88. What is the difference between the CO2 emissions (% of total fuel combustion) in Latin America(all income levels) in 2006 and the CO2 emissions (% of total fuel combustion) in Kosovo in 2007?
Provide a succinct answer. 3.86. What is the difference between the CO2 emissions (% of total fuel combustion) in Latin America(all income levels) in 2006 and the CO2 emissions (% of total fuel combustion) in Macedonia in 2007?
Your response must be concise. 1.9. What is the difference between the CO2 emissions (% of total fuel combustion) in Middle income in 2006 and the CO2 emissions (% of total fuel combustion) in Kosovo in 2007?
Offer a very short reply. 4.92. What is the difference between the CO2 emissions (% of total fuel combustion) of Middle income in 2006 and the CO2 emissions (% of total fuel combustion) of Macedonia in 2007?
Your response must be concise. 2.96. What is the difference between the CO2 emissions (% of total fuel combustion) in Kosovo in 2006 and the CO2 emissions (% of total fuel combustion) in Macedonia in 2007?
Offer a terse response. -1.81. What is the average CO2 emissions (% of total fuel combustion) of Latin America(all income levels) per year?
Provide a short and direct response. 7.38. What is the average CO2 emissions (% of total fuel combustion) in Middle income per year?
Your answer should be very brief. 8.6. What is the average CO2 emissions (% of total fuel combustion) of Kosovo per year?
Your answer should be compact. 3.07. What is the average CO2 emissions (% of total fuel combustion) of Macedonia per year?
Offer a very short reply. 4.92. In the year 2000, what is the difference between the CO2 emissions (% of total fuel combustion) of Latin America(all income levels) and CO2 emissions (% of total fuel combustion) of Middle income?
Your answer should be very brief. -1.52. In the year 2000, what is the difference between the CO2 emissions (% of total fuel combustion) of Latin America(all income levels) and CO2 emissions (% of total fuel combustion) of Kosovo?
Make the answer very short. 4.7. In the year 2000, what is the difference between the CO2 emissions (% of total fuel combustion) in Latin America(all income levels) and CO2 emissions (% of total fuel combustion) in Macedonia?
Your response must be concise. 5.15. In the year 2000, what is the difference between the CO2 emissions (% of total fuel combustion) in Middle income and CO2 emissions (% of total fuel combustion) in Kosovo?
Give a very brief answer. 6.22. In the year 2000, what is the difference between the CO2 emissions (% of total fuel combustion) of Middle income and CO2 emissions (% of total fuel combustion) of Macedonia?
Make the answer very short. 6.67. In the year 2000, what is the difference between the CO2 emissions (% of total fuel combustion) in Kosovo and CO2 emissions (% of total fuel combustion) in Macedonia?
Give a very brief answer. 0.45. In the year 2001, what is the difference between the CO2 emissions (% of total fuel combustion) in Latin America(all income levels) and CO2 emissions (% of total fuel combustion) in Middle income?
Your answer should be very brief. -1.46. In the year 2001, what is the difference between the CO2 emissions (% of total fuel combustion) in Latin America(all income levels) and CO2 emissions (% of total fuel combustion) in Kosovo?
Your answer should be very brief. 4.62. In the year 2001, what is the difference between the CO2 emissions (% of total fuel combustion) in Latin America(all income levels) and CO2 emissions (% of total fuel combustion) in Macedonia?
Provide a succinct answer. 5.3. In the year 2001, what is the difference between the CO2 emissions (% of total fuel combustion) in Middle income and CO2 emissions (% of total fuel combustion) in Kosovo?
Offer a terse response. 6.08. In the year 2001, what is the difference between the CO2 emissions (% of total fuel combustion) of Middle income and CO2 emissions (% of total fuel combustion) of Macedonia?
Keep it short and to the point. 6.76. In the year 2001, what is the difference between the CO2 emissions (% of total fuel combustion) in Kosovo and CO2 emissions (% of total fuel combustion) in Macedonia?
Your answer should be compact. 0.68. In the year 2002, what is the difference between the CO2 emissions (% of total fuel combustion) of Latin America(all income levels) and CO2 emissions (% of total fuel combustion) of Middle income?
Your answer should be very brief. -1.39. In the year 2002, what is the difference between the CO2 emissions (% of total fuel combustion) of Latin America(all income levels) and CO2 emissions (% of total fuel combustion) of Kosovo?
Keep it short and to the point. 4.57. In the year 2002, what is the difference between the CO2 emissions (% of total fuel combustion) in Latin America(all income levels) and CO2 emissions (% of total fuel combustion) in Macedonia?
Keep it short and to the point. 2.62. In the year 2002, what is the difference between the CO2 emissions (% of total fuel combustion) in Middle income and CO2 emissions (% of total fuel combustion) in Kosovo?
Keep it short and to the point. 5.96. In the year 2002, what is the difference between the CO2 emissions (% of total fuel combustion) in Middle income and CO2 emissions (% of total fuel combustion) in Macedonia?
Provide a succinct answer. 4.01. In the year 2002, what is the difference between the CO2 emissions (% of total fuel combustion) in Kosovo and CO2 emissions (% of total fuel combustion) in Macedonia?
Keep it short and to the point. -1.95. In the year 2003, what is the difference between the CO2 emissions (% of total fuel combustion) in Latin America(all income levels) and CO2 emissions (% of total fuel combustion) in Middle income?
Offer a terse response. -1.35. In the year 2003, what is the difference between the CO2 emissions (% of total fuel combustion) in Latin America(all income levels) and CO2 emissions (% of total fuel combustion) in Kosovo?
Offer a terse response. 4.16. In the year 2003, what is the difference between the CO2 emissions (% of total fuel combustion) in Latin America(all income levels) and CO2 emissions (% of total fuel combustion) in Macedonia?
Give a very brief answer. 0.76. In the year 2003, what is the difference between the CO2 emissions (% of total fuel combustion) of Middle income and CO2 emissions (% of total fuel combustion) of Kosovo?
Your response must be concise. 5.52. In the year 2003, what is the difference between the CO2 emissions (% of total fuel combustion) in Middle income and CO2 emissions (% of total fuel combustion) in Macedonia?
Make the answer very short. 2.11. In the year 2003, what is the difference between the CO2 emissions (% of total fuel combustion) of Kosovo and CO2 emissions (% of total fuel combustion) of Macedonia?
Keep it short and to the point. -3.4. In the year 2004, what is the difference between the CO2 emissions (% of total fuel combustion) in Latin America(all income levels) and CO2 emissions (% of total fuel combustion) in Middle income?
Keep it short and to the point. -1.29. In the year 2004, what is the difference between the CO2 emissions (% of total fuel combustion) in Latin America(all income levels) and CO2 emissions (% of total fuel combustion) in Kosovo?
Keep it short and to the point. 4.55. In the year 2004, what is the difference between the CO2 emissions (% of total fuel combustion) of Latin America(all income levels) and CO2 emissions (% of total fuel combustion) of Macedonia?
Make the answer very short. 1.17. In the year 2004, what is the difference between the CO2 emissions (% of total fuel combustion) of Middle income and CO2 emissions (% of total fuel combustion) of Kosovo?
Provide a succinct answer. 5.84. In the year 2004, what is the difference between the CO2 emissions (% of total fuel combustion) in Middle income and CO2 emissions (% of total fuel combustion) in Macedonia?
Provide a short and direct response. 2.46. In the year 2004, what is the difference between the CO2 emissions (% of total fuel combustion) of Kosovo and CO2 emissions (% of total fuel combustion) of Macedonia?
Provide a succinct answer. -3.38. In the year 2005, what is the difference between the CO2 emissions (% of total fuel combustion) in Latin America(all income levels) and CO2 emissions (% of total fuel combustion) in Middle income?
Provide a succinct answer. -1.17. In the year 2005, what is the difference between the CO2 emissions (% of total fuel combustion) in Latin America(all income levels) and CO2 emissions (% of total fuel combustion) in Kosovo?
Offer a very short reply. 3.91. In the year 2005, what is the difference between the CO2 emissions (% of total fuel combustion) in Latin America(all income levels) and CO2 emissions (% of total fuel combustion) in Macedonia?
Your answer should be very brief. 0.93. In the year 2005, what is the difference between the CO2 emissions (% of total fuel combustion) in Middle income and CO2 emissions (% of total fuel combustion) in Kosovo?
Offer a very short reply. 5.08. In the year 2005, what is the difference between the CO2 emissions (% of total fuel combustion) of Middle income and CO2 emissions (% of total fuel combustion) of Macedonia?
Give a very brief answer. 2.1. In the year 2005, what is the difference between the CO2 emissions (% of total fuel combustion) of Kosovo and CO2 emissions (% of total fuel combustion) of Macedonia?
Keep it short and to the point. -2.98. In the year 2006, what is the difference between the CO2 emissions (% of total fuel combustion) of Latin America(all income levels) and CO2 emissions (% of total fuel combustion) of Middle income?
Ensure brevity in your answer.  -1.06. In the year 2006, what is the difference between the CO2 emissions (% of total fuel combustion) of Latin America(all income levels) and CO2 emissions (% of total fuel combustion) of Kosovo?
Your answer should be compact. 3.71. In the year 2006, what is the difference between the CO2 emissions (% of total fuel combustion) of Latin America(all income levels) and CO2 emissions (% of total fuel combustion) of Macedonia?
Your response must be concise. 1.43. In the year 2006, what is the difference between the CO2 emissions (% of total fuel combustion) of Middle income and CO2 emissions (% of total fuel combustion) of Kosovo?
Keep it short and to the point. 4.77. In the year 2006, what is the difference between the CO2 emissions (% of total fuel combustion) of Middle income and CO2 emissions (% of total fuel combustion) of Macedonia?
Make the answer very short. 2.48. In the year 2006, what is the difference between the CO2 emissions (% of total fuel combustion) in Kosovo and CO2 emissions (% of total fuel combustion) in Macedonia?
Your response must be concise. -2.29. In the year 2007, what is the difference between the CO2 emissions (% of total fuel combustion) in Latin America(all income levels) and CO2 emissions (% of total fuel combustion) in Middle income?
Your answer should be compact. -0.53. In the year 2007, what is the difference between the CO2 emissions (% of total fuel combustion) of Latin America(all income levels) and CO2 emissions (% of total fuel combustion) of Kosovo?
Give a very brief answer. 4.21. In the year 2007, what is the difference between the CO2 emissions (% of total fuel combustion) of Latin America(all income levels) and CO2 emissions (% of total fuel combustion) of Macedonia?
Offer a very short reply. 2.25. In the year 2007, what is the difference between the CO2 emissions (% of total fuel combustion) of Middle income and CO2 emissions (% of total fuel combustion) of Kosovo?
Provide a short and direct response. 4.74. In the year 2007, what is the difference between the CO2 emissions (% of total fuel combustion) of Middle income and CO2 emissions (% of total fuel combustion) of Macedonia?
Make the answer very short. 2.78. In the year 2007, what is the difference between the CO2 emissions (% of total fuel combustion) in Kosovo and CO2 emissions (% of total fuel combustion) in Macedonia?
Provide a succinct answer. -1.96. What is the ratio of the CO2 emissions (% of total fuel combustion) in Latin America(all income levels) in 2000 to that in 2001?
Offer a very short reply. 1.02. What is the ratio of the CO2 emissions (% of total fuel combustion) of Middle income in 2000 to that in 2001?
Provide a succinct answer. 1.02. What is the ratio of the CO2 emissions (% of total fuel combustion) of Kosovo in 2000 to that in 2001?
Give a very brief answer. 1.01. What is the ratio of the CO2 emissions (% of total fuel combustion) of Macedonia in 2000 to that in 2001?
Your response must be concise. 1.11. What is the ratio of the CO2 emissions (% of total fuel combustion) of Latin America(all income levels) in 2000 to that in 2002?
Provide a succinct answer. 1.02. What is the ratio of the CO2 emissions (% of total fuel combustion) in Middle income in 2000 to that in 2002?
Your answer should be compact. 1.03. What is the ratio of the CO2 emissions (% of total fuel combustion) of Kosovo in 2000 to that in 2002?
Your answer should be compact. 1.01. What is the ratio of the CO2 emissions (% of total fuel combustion) in Macedonia in 2000 to that in 2002?
Your answer should be very brief. 0.54. What is the ratio of the CO2 emissions (% of total fuel combustion) in Latin America(all income levels) in 2000 to that in 2003?
Keep it short and to the point. 1.08. What is the ratio of the CO2 emissions (% of total fuel combustion) of Middle income in 2000 to that in 2003?
Your response must be concise. 1.08. What is the ratio of the CO2 emissions (% of total fuel combustion) of Kosovo in 2000 to that in 2003?
Provide a short and direct response. 1.01. What is the ratio of the CO2 emissions (% of total fuel combustion) in Macedonia in 2000 to that in 2003?
Offer a very short reply. 0.42. What is the ratio of the CO2 emissions (% of total fuel combustion) in Latin America(all income levels) in 2000 to that in 2004?
Keep it short and to the point. 1.09. What is the ratio of the CO2 emissions (% of total fuel combustion) of Middle income in 2000 to that in 2004?
Provide a short and direct response. 1.1. What is the ratio of the CO2 emissions (% of total fuel combustion) in Kosovo in 2000 to that in 2004?
Make the answer very short. 1.19. What is the ratio of the CO2 emissions (% of total fuel combustion) in Macedonia in 2000 to that in 2004?
Provide a short and direct response. 0.45. What is the ratio of the CO2 emissions (% of total fuel combustion) of Latin America(all income levels) in 2000 to that in 2005?
Offer a very short reply. 1.13. What is the ratio of the CO2 emissions (% of total fuel combustion) in Middle income in 2000 to that in 2005?
Keep it short and to the point. 1.16. What is the ratio of the CO2 emissions (% of total fuel combustion) in Kosovo in 2000 to that in 2005?
Provide a succinct answer. 1.04. What is the ratio of the CO2 emissions (% of total fuel combustion) of Macedonia in 2000 to that in 2005?
Your response must be concise. 0.45. What is the ratio of the CO2 emissions (% of total fuel combustion) in Latin America(all income levels) in 2000 to that in 2006?
Your answer should be compact. 1.14. What is the ratio of the CO2 emissions (% of total fuel combustion) in Middle income in 2000 to that in 2006?
Your response must be concise. 1.18. What is the ratio of the CO2 emissions (% of total fuel combustion) in Kosovo in 2000 to that in 2006?
Offer a terse response. 1. What is the ratio of the CO2 emissions (% of total fuel combustion) in Macedonia in 2000 to that in 2006?
Provide a short and direct response. 0.5. What is the ratio of the CO2 emissions (% of total fuel combustion) in Latin America(all income levels) in 2000 to that in 2007?
Your response must be concise. 1.09. What is the ratio of the CO2 emissions (% of total fuel combustion) in Middle income in 2000 to that in 2007?
Your response must be concise. 1.21. What is the ratio of the CO2 emissions (% of total fuel combustion) of Kosovo in 2000 to that in 2007?
Provide a short and direct response. 1.05. What is the ratio of the CO2 emissions (% of total fuel combustion) in Macedonia in 2000 to that in 2007?
Provide a succinct answer. 0.55. What is the ratio of the CO2 emissions (% of total fuel combustion) in Latin America(all income levels) in 2001 to that in 2002?
Offer a terse response. 1. What is the ratio of the CO2 emissions (% of total fuel combustion) in Middle income in 2001 to that in 2002?
Ensure brevity in your answer.  1.01. What is the ratio of the CO2 emissions (% of total fuel combustion) in Macedonia in 2001 to that in 2002?
Offer a terse response. 0.48. What is the ratio of the CO2 emissions (% of total fuel combustion) of Latin America(all income levels) in 2001 to that in 2003?
Give a very brief answer. 1.06. What is the ratio of the CO2 emissions (% of total fuel combustion) of Middle income in 2001 to that in 2003?
Your response must be concise. 1.06. What is the ratio of the CO2 emissions (% of total fuel combustion) of Macedonia in 2001 to that in 2003?
Your answer should be very brief. 0.37. What is the ratio of the CO2 emissions (% of total fuel combustion) in Latin America(all income levels) in 2001 to that in 2004?
Keep it short and to the point. 1.07. What is the ratio of the CO2 emissions (% of total fuel combustion) of Middle income in 2001 to that in 2004?
Give a very brief answer. 1.08. What is the ratio of the CO2 emissions (% of total fuel combustion) in Kosovo in 2001 to that in 2004?
Offer a terse response. 1.17. What is the ratio of the CO2 emissions (% of total fuel combustion) of Macedonia in 2001 to that in 2004?
Make the answer very short. 0.41. What is the ratio of the CO2 emissions (% of total fuel combustion) of Latin America(all income levels) in 2001 to that in 2005?
Give a very brief answer. 1.11. What is the ratio of the CO2 emissions (% of total fuel combustion) of Middle income in 2001 to that in 2005?
Keep it short and to the point. 1.13. What is the ratio of the CO2 emissions (% of total fuel combustion) in Kosovo in 2001 to that in 2005?
Ensure brevity in your answer.  1.03. What is the ratio of the CO2 emissions (% of total fuel combustion) in Macedonia in 2001 to that in 2005?
Your answer should be compact. 0.41. What is the ratio of the CO2 emissions (% of total fuel combustion) of Latin America(all income levels) in 2001 to that in 2006?
Offer a terse response. 1.13. What is the ratio of the CO2 emissions (% of total fuel combustion) of Middle income in 2001 to that in 2006?
Make the answer very short. 1.16. What is the ratio of the CO2 emissions (% of total fuel combustion) of Kosovo in 2001 to that in 2006?
Provide a short and direct response. 0.99. What is the ratio of the CO2 emissions (% of total fuel combustion) in Macedonia in 2001 to that in 2006?
Your answer should be compact. 0.45. What is the ratio of the CO2 emissions (% of total fuel combustion) of Latin America(all income levels) in 2001 to that in 2007?
Your answer should be very brief. 1.07. What is the ratio of the CO2 emissions (% of total fuel combustion) in Middle income in 2001 to that in 2007?
Give a very brief answer. 1.19. What is the ratio of the CO2 emissions (% of total fuel combustion) in Kosovo in 2001 to that in 2007?
Give a very brief answer. 1.03. What is the ratio of the CO2 emissions (% of total fuel combustion) in Macedonia in 2001 to that in 2007?
Your answer should be very brief. 0.49. What is the ratio of the CO2 emissions (% of total fuel combustion) of Latin America(all income levels) in 2002 to that in 2003?
Make the answer very short. 1.06. What is the ratio of the CO2 emissions (% of total fuel combustion) in Middle income in 2002 to that in 2003?
Keep it short and to the point. 1.05. What is the ratio of the CO2 emissions (% of total fuel combustion) in Macedonia in 2002 to that in 2003?
Provide a succinct answer. 0.78. What is the ratio of the CO2 emissions (% of total fuel combustion) in Latin America(all income levels) in 2002 to that in 2004?
Your answer should be compact. 1.07. What is the ratio of the CO2 emissions (% of total fuel combustion) of Middle income in 2002 to that in 2004?
Make the answer very short. 1.07. What is the ratio of the CO2 emissions (% of total fuel combustion) of Kosovo in 2002 to that in 2004?
Your answer should be compact. 1.18. What is the ratio of the CO2 emissions (% of total fuel combustion) of Macedonia in 2002 to that in 2004?
Make the answer very short. 0.84. What is the ratio of the CO2 emissions (% of total fuel combustion) of Latin America(all income levels) in 2002 to that in 2005?
Provide a succinct answer. 1.11. What is the ratio of the CO2 emissions (% of total fuel combustion) of Middle income in 2002 to that in 2005?
Make the answer very short. 1.12. What is the ratio of the CO2 emissions (% of total fuel combustion) in Kosovo in 2002 to that in 2005?
Offer a terse response. 1.03. What is the ratio of the CO2 emissions (% of total fuel combustion) of Macedonia in 2002 to that in 2005?
Your response must be concise. 0.85. What is the ratio of the CO2 emissions (% of total fuel combustion) of Latin America(all income levels) in 2002 to that in 2006?
Ensure brevity in your answer.  1.12. What is the ratio of the CO2 emissions (% of total fuel combustion) of Middle income in 2002 to that in 2006?
Your answer should be very brief. 1.15. What is the ratio of the CO2 emissions (% of total fuel combustion) in Kosovo in 2002 to that in 2006?
Offer a very short reply. 0.99. What is the ratio of the CO2 emissions (% of total fuel combustion) of Macedonia in 2002 to that in 2006?
Your answer should be very brief. 0.93. What is the ratio of the CO2 emissions (% of total fuel combustion) of Latin America(all income levels) in 2002 to that in 2007?
Provide a short and direct response. 1.07. What is the ratio of the CO2 emissions (% of total fuel combustion) of Middle income in 2002 to that in 2007?
Your answer should be compact. 1.17. What is the ratio of the CO2 emissions (% of total fuel combustion) of Kosovo in 2002 to that in 2007?
Your response must be concise. 1.04. What is the ratio of the CO2 emissions (% of total fuel combustion) of Macedonia in 2002 to that in 2007?
Ensure brevity in your answer.  1.02. What is the ratio of the CO2 emissions (% of total fuel combustion) of Latin America(all income levels) in 2003 to that in 2004?
Your answer should be very brief. 1.01. What is the ratio of the CO2 emissions (% of total fuel combustion) in Middle income in 2003 to that in 2004?
Keep it short and to the point. 1.02. What is the ratio of the CO2 emissions (% of total fuel combustion) of Kosovo in 2003 to that in 2004?
Give a very brief answer. 1.18. What is the ratio of the CO2 emissions (% of total fuel combustion) in Macedonia in 2003 to that in 2004?
Give a very brief answer. 1.08. What is the ratio of the CO2 emissions (% of total fuel combustion) in Latin America(all income levels) in 2003 to that in 2005?
Ensure brevity in your answer.  1.05. What is the ratio of the CO2 emissions (% of total fuel combustion) of Middle income in 2003 to that in 2005?
Your answer should be compact. 1.07. What is the ratio of the CO2 emissions (% of total fuel combustion) of Kosovo in 2003 to that in 2005?
Provide a short and direct response. 1.03. What is the ratio of the CO2 emissions (% of total fuel combustion) in Macedonia in 2003 to that in 2005?
Make the answer very short. 1.09. What is the ratio of the CO2 emissions (% of total fuel combustion) of Latin America(all income levels) in 2003 to that in 2006?
Your response must be concise. 1.06. What is the ratio of the CO2 emissions (% of total fuel combustion) of Middle income in 2003 to that in 2006?
Your answer should be very brief. 1.09. What is the ratio of the CO2 emissions (% of total fuel combustion) of Macedonia in 2003 to that in 2006?
Your answer should be very brief. 1.2. What is the ratio of the CO2 emissions (% of total fuel combustion) of Latin America(all income levels) in 2003 to that in 2007?
Make the answer very short. 1.01. What is the ratio of the CO2 emissions (% of total fuel combustion) of Middle income in 2003 to that in 2007?
Give a very brief answer. 1.12. What is the ratio of the CO2 emissions (% of total fuel combustion) of Kosovo in 2003 to that in 2007?
Keep it short and to the point. 1.04. What is the ratio of the CO2 emissions (% of total fuel combustion) in Macedonia in 2003 to that in 2007?
Your response must be concise. 1.31. What is the ratio of the CO2 emissions (% of total fuel combustion) in Latin America(all income levels) in 2004 to that in 2005?
Offer a very short reply. 1.04. What is the ratio of the CO2 emissions (% of total fuel combustion) in Middle income in 2004 to that in 2005?
Provide a succinct answer. 1.05. What is the ratio of the CO2 emissions (% of total fuel combustion) in Kosovo in 2004 to that in 2005?
Your answer should be very brief. 0.87. What is the ratio of the CO2 emissions (% of total fuel combustion) in Macedonia in 2004 to that in 2005?
Your answer should be compact. 1. What is the ratio of the CO2 emissions (% of total fuel combustion) of Latin America(all income levels) in 2004 to that in 2006?
Ensure brevity in your answer.  1.05. What is the ratio of the CO2 emissions (% of total fuel combustion) in Middle income in 2004 to that in 2006?
Provide a short and direct response. 1.07. What is the ratio of the CO2 emissions (% of total fuel combustion) in Kosovo in 2004 to that in 2006?
Provide a short and direct response. 0.84. What is the ratio of the CO2 emissions (% of total fuel combustion) of Macedonia in 2004 to that in 2006?
Ensure brevity in your answer.  1.11. What is the ratio of the CO2 emissions (% of total fuel combustion) in Middle income in 2004 to that in 2007?
Give a very brief answer. 1.1. What is the ratio of the CO2 emissions (% of total fuel combustion) in Kosovo in 2004 to that in 2007?
Give a very brief answer. 0.88. What is the ratio of the CO2 emissions (% of total fuel combustion) of Macedonia in 2004 to that in 2007?
Your answer should be very brief. 1.21. What is the ratio of the CO2 emissions (% of total fuel combustion) in Latin America(all income levels) in 2005 to that in 2006?
Offer a very short reply. 1.01. What is the ratio of the CO2 emissions (% of total fuel combustion) of Middle income in 2005 to that in 2006?
Your response must be concise. 1.02. What is the ratio of the CO2 emissions (% of total fuel combustion) in Kosovo in 2005 to that in 2006?
Provide a succinct answer. 0.96. What is the ratio of the CO2 emissions (% of total fuel combustion) in Macedonia in 2005 to that in 2006?
Keep it short and to the point. 1.1. What is the ratio of the CO2 emissions (% of total fuel combustion) in Latin America(all income levels) in 2005 to that in 2007?
Make the answer very short. 0.96. What is the ratio of the CO2 emissions (% of total fuel combustion) in Middle income in 2005 to that in 2007?
Keep it short and to the point. 1.05. What is the ratio of the CO2 emissions (% of total fuel combustion) in Kosovo in 2005 to that in 2007?
Your answer should be compact. 1.01. What is the ratio of the CO2 emissions (% of total fuel combustion) in Macedonia in 2005 to that in 2007?
Provide a short and direct response. 1.21. What is the ratio of the CO2 emissions (% of total fuel combustion) in Latin America(all income levels) in 2006 to that in 2007?
Offer a very short reply. 0.95. What is the ratio of the CO2 emissions (% of total fuel combustion) in Middle income in 2006 to that in 2007?
Your response must be concise. 1.02. What is the ratio of the CO2 emissions (% of total fuel combustion) in Macedonia in 2006 to that in 2007?
Your answer should be very brief. 1.1. What is the difference between the highest and the second highest CO2 emissions (% of total fuel combustion) in Latin America(all income levels)?
Provide a short and direct response. 0.13. What is the difference between the highest and the second highest CO2 emissions (% of total fuel combustion) in Middle income?
Your answer should be very brief. 0.18. What is the difference between the highest and the second highest CO2 emissions (% of total fuel combustion) of Kosovo?
Offer a terse response. 0. What is the difference between the highest and the second highest CO2 emissions (% of total fuel combustion) in Macedonia?
Give a very brief answer. 0.5. What is the difference between the highest and the lowest CO2 emissions (% of total fuel combustion) in Latin America(all income levels)?
Offer a very short reply. 0.99. What is the difference between the highest and the lowest CO2 emissions (% of total fuel combustion) of Middle income?
Ensure brevity in your answer.  1.63. What is the difference between the highest and the lowest CO2 emissions (% of total fuel combustion) in Kosovo?
Offer a very short reply. 0.51. What is the difference between the highest and the lowest CO2 emissions (% of total fuel combustion) in Macedonia?
Ensure brevity in your answer.  4.1. 